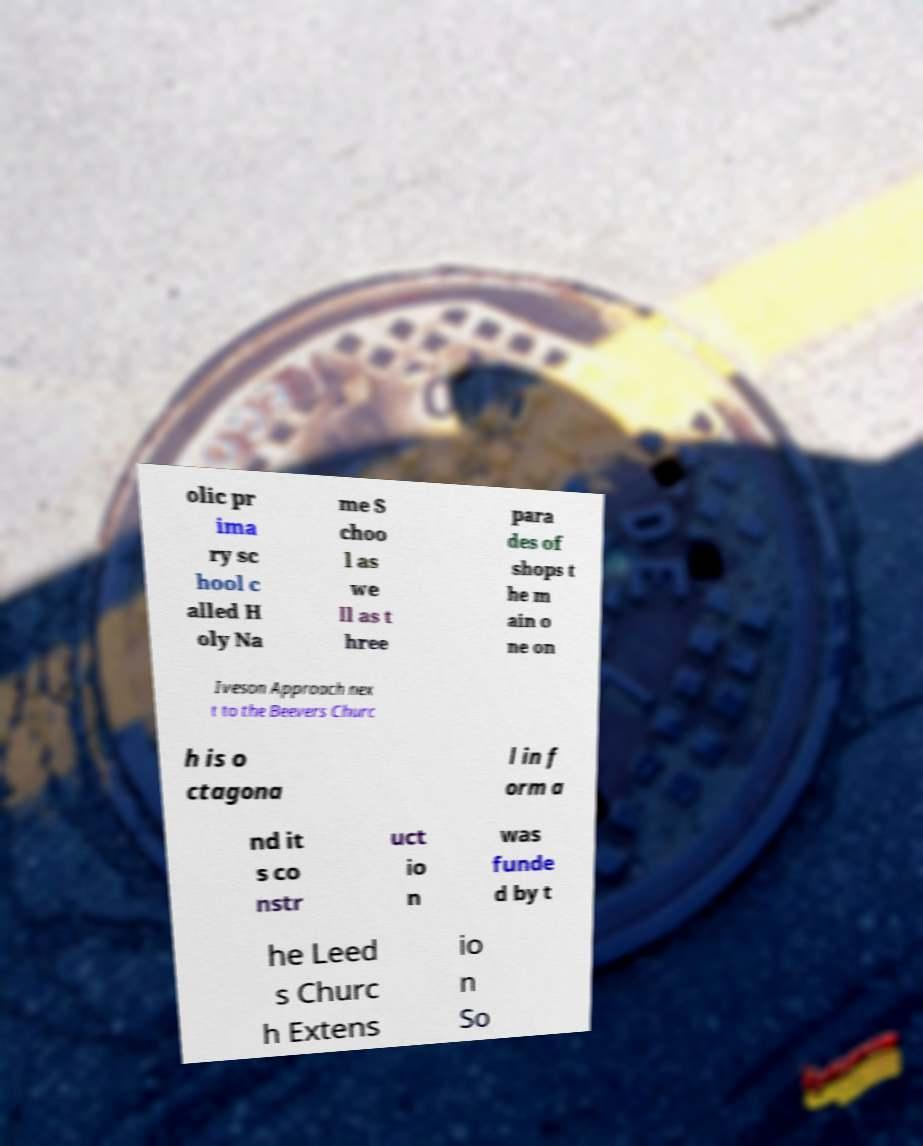For documentation purposes, I need the text within this image transcribed. Could you provide that? olic pr ima ry sc hool c alled H oly Na me S choo l as we ll as t hree para des of shops t he m ain o ne on Iveson Approach nex t to the Beevers Churc h is o ctagona l in f orm a nd it s co nstr uct io n was funde d by t he Leed s Churc h Extens io n So 